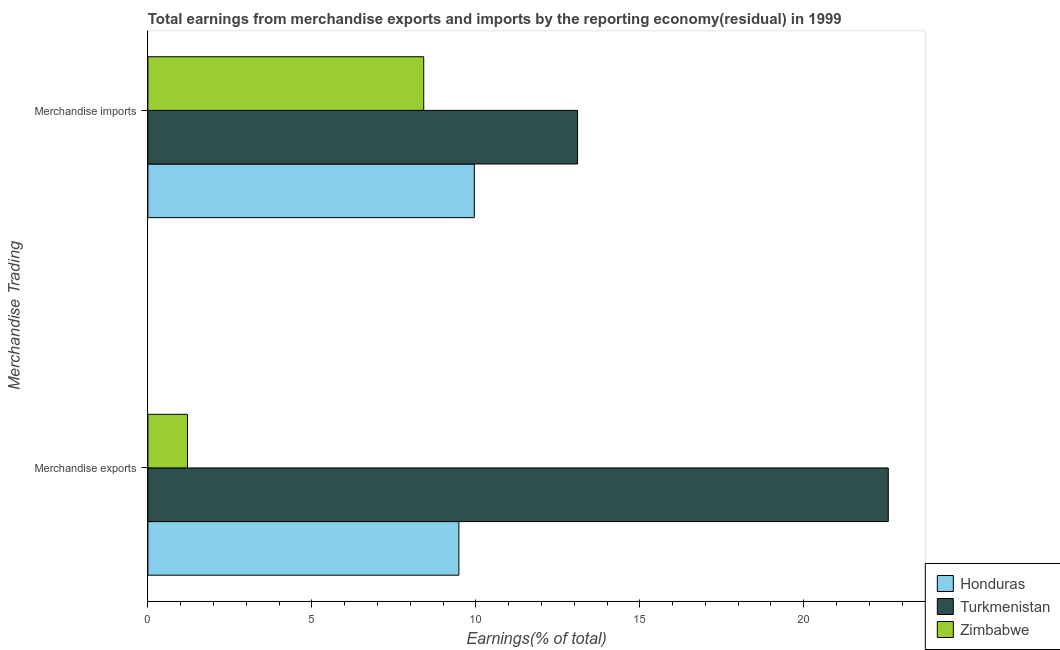How many groups of bars are there?
Offer a very short reply. 2. How many bars are there on the 1st tick from the top?
Your response must be concise. 3. How many bars are there on the 2nd tick from the bottom?
Make the answer very short. 3. What is the label of the 2nd group of bars from the top?
Provide a succinct answer. Merchandise exports. What is the earnings from merchandise imports in Honduras?
Offer a very short reply. 9.95. Across all countries, what is the maximum earnings from merchandise exports?
Make the answer very short. 22.58. Across all countries, what is the minimum earnings from merchandise imports?
Offer a very short reply. 8.41. In which country was the earnings from merchandise imports maximum?
Your answer should be compact. Turkmenistan. In which country was the earnings from merchandise imports minimum?
Keep it short and to the point. Zimbabwe. What is the total earnings from merchandise exports in the graph?
Provide a succinct answer. 33.27. What is the difference between the earnings from merchandise exports in Honduras and that in Turkmenistan?
Provide a short and direct response. -13.09. What is the difference between the earnings from merchandise imports in Honduras and the earnings from merchandise exports in Turkmenistan?
Provide a succinct answer. -12.62. What is the average earnings from merchandise exports per country?
Give a very brief answer. 11.09. What is the difference between the earnings from merchandise exports and earnings from merchandise imports in Turkmenistan?
Your answer should be compact. 9.47. In how many countries, is the earnings from merchandise imports greater than 14 %?
Make the answer very short. 0. What is the ratio of the earnings from merchandise exports in Turkmenistan to that in Honduras?
Make the answer very short. 2.38. Is the earnings from merchandise imports in Turkmenistan less than that in Honduras?
Provide a short and direct response. No. In how many countries, is the earnings from merchandise exports greater than the average earnings from merchandise exports taken over all countries?
Keep it short and to the point. 1. What does the 2nd bar from the top in Merchandise imports represents?
Provide a short and direct response. Turkmenistan. What does the 3rd bar from the bottom in Merchandise imports represents?
Provide a short and direct response. Zimbabwe. How many bars are there?
Keep it short and to the point. 6. Are all the bars in the graph horizontal?
Ensure brevity in your answer.  Yes. What is the difference between two consecutive major ticks on the X-axis?
Ensure brevity in your answer.  5. How many legend labels are there?
Provide a succinct answer. 3. What is the title of the graph?
Give a very brief answer. Total earnings from merchandise exports and imports by the reporting economy(residual) in 1999. Does "Bahrain" appear as one of the legend labels in the graph?
Provide a short and direct response. No. What is the label or title of the X-axis?
Provide a short and direct response. Earnings(% of total). What is the label or title of the Y-axis?
Keep it short and to the point. Merchandise Trading. What is the Earnings(% of total) of Honduras in Merchandise exports?
Your response must be concise. 9.48. What is the Earnings(% of total) of Turkmenistan in Merchandise exports?
Offer a very short reply. 22.58. What is the Earnings(% of total) in Zimbabwe in Merchandise exports?
Give a very brief answer. 1.21. What is the Earnings(% of total) in Honduras in Merchandise imports?
Your response must be concise. 9.95. What is the Earnings(% of total) in Turkmenistan in Merchandise imports?
Offer a terse response. 13.1. What is the Earnings(% of total) in Zimbabwe in Merchandise imports?
Your answer should be compact. 8.41. Across all Merchandise Trading, what is the maximum Earnings(% of total) in Honduras?
Your answer should be compact. 9.95. Across all Merchandise Trading, what is the maximum Earnings(% of total) of Turkmenistan?
Keep it short and to the point. 22.58. Across all Merchandise Trading, what is the maximum Earnings(% of total) in Zimbabwe?
Provide a short and direct response. 8.41. Across all Merchandise Trading, what is the minimum Earnings(% of total) in Honduras?
Your response must be concise. 9.48. Across all Merchandise Trading, what is the minimum Earnings(% of total) in Turkmenistan?
Your answer should be very brief. 13.1. Across all Merchandise Trading, what is the minimum Earnings(% of total) of Zimbabwe?
Offer a very short reply. 1.21. What is the total Earnings(% of total) of Honduras in the graph?
Provide a succinct answer. 19.44. What is the total Earnings(% of total) in Turkmenistan in the graph?
Provide a short and direct response. 35.68. What is the total Earnings(% of total) in Zimbabwe in the graph?
Keep it short and to the point. 9.62. What is the difference between the Earnings(% of total) of Honduras in Merchandise exports and that in Merchandise imports?
Provide a short and direct response. -0.47. What is the difference between the Earnings(% of total) in Turkmenistan in Merchandise exports and that in Merchandise imports?
Your answer should be very brief. 9.47. What is the difference between the Earnings(% of total) in Zimbabwe in Merchandise exports and that in Merchandise imports?
Ensure brevity in your answer.  -7.2. What is the difference between the Earnings(% of total) in Honduras in Merchandise exports and the Earnings(% of total) in Turkmenistan in Merchandise imports?
Your answer should be compact. -3.62. What is the difference between the Earnings(% of total) in Honduras in Merchandise exports and the Earnings(% of total) in Zimbabwe in Merchandise imports?
Offer a terse response. 1.07. What is the difference between the Earnings(% of total) of Turkmenistan in Merchandise exports and the Earnings(% of total) of Zimbabwe in Merchandise imports?
Offer a terse response. 14.17. What is the average Earnings(% of total) in Honduras per Merchandise Trading?
Offer a very short reply. 9.72. What is the average Earnings(% of total) of Turkmenistan per Merchandise Trading?
Your answer should be compact. 17.84. What is the average Earnings(% of total) in Zimbabwe per Merchandise Trading?
Give a very brief answer. 4.81. What is the difference between the Earnings(% of total) in Honduras and Earnings(% of total) in Turkmenistan in Merchandise exports?
Make the answer very short. -13.09. What is the difference between the Earnings(% of total) in Honduras and Earnings(% of total) in Zimbabwe in Merchandise exports?
Offer a terse response. 8.28. What is the difference between the Earnings(% of total) in Turkmenistan and Earnings(% of total) in Zimbabwe in Merchandise exports?
Give a very brief answer. 21.37. What is the difference between the Earnings(% of total) of Honduras and Earnings(% of total) of Turkmenistan in Merchandise imports?
Offer a very short reply. -3.15. What is the difference between the Earnings(% of total) of Honduras and Earnings(% of total) of Zimbabwe in Merchandise imports?
Give a very brief answer. 1.54. What is the difference between the Earnings(% of total) in Turkmenistan and Earnings(% of total) in Zimbabwe in Merchandise imports?
Your answer should be compact. 4.69. What is the ratio of the Earnings(% of total) of Honduras in Merchandise exports to that in Merchandise imports?
Offer a very short reply. 0.95. What is the ratio of the Earnings(% of total) in Turkmenistan in Merchandise exports to that in Merchandise imports?
Offer a very short reply. 1.72. What is the ratio of the Earnings(% of total) in Zimbabwe in Merchandise exports to that in Merchandise imports?
Your answer should be very brief. 0.14. What is the difference between the highest and the second highest Earnings(% of total) in Honduras?
Your answer should be very brief. 0.47. What is the difference between the highest and the second highest Earnings(% of total) in Turkmenistan?
Offer a terse response. 9.47. What is the difference between the highest and the second highest Earnings(% of total) in Zimbabwe?
Your response must be concise. 7.2. What is the difference between the highest and the lowest Earnings(% of total) in Honduras?
Offer a very short reply. 0.47. What is the difference between the highest and the lowest Earnings(% of total) of Turkmenistan?
Make the answer very short. 9.47. What is the difference between the highest and the lowest Earnings(% of total) in Zimbabwe?
Keep it short and to the point. 7.2. 